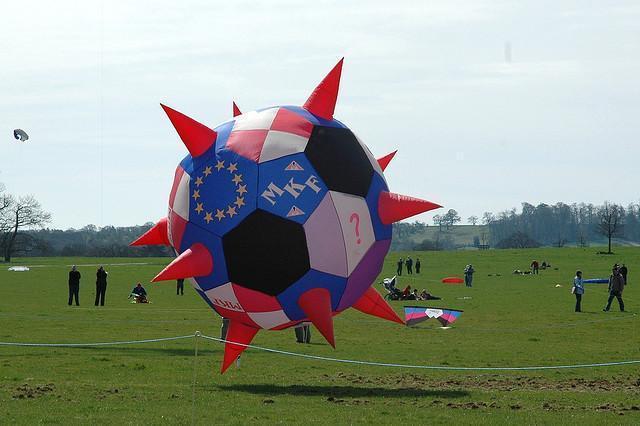How many people are there?
Give a very brief answer. 1. 